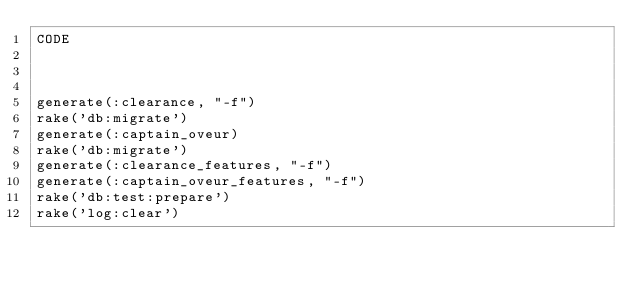<code> <loc_0><loc_0><loc_500><loc_500><_Ruby_>CODE



generate(:clearance, "-f")
rake('db:migrate')
generate(:captain_oveur)
rake('db:migrate')
generate(:clearance_features, "-f")
generate(:captain_oveur_features, "-f")
rake('db:test:prepare')
rake('log:clear')
</code> 